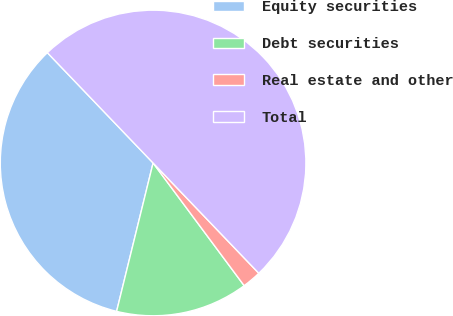Convert chart to OTSL. <chart><loc_0><loc_0><loc_500><loc_500><pie_chart><fcel>Equity securities<fcel>Debt securities<fcel>Real estate and other<fcel>Total<nl><fcel>34.0%<fcel>14.0%<fcel>2.0%<fcel>50.0%<nl></chart> 